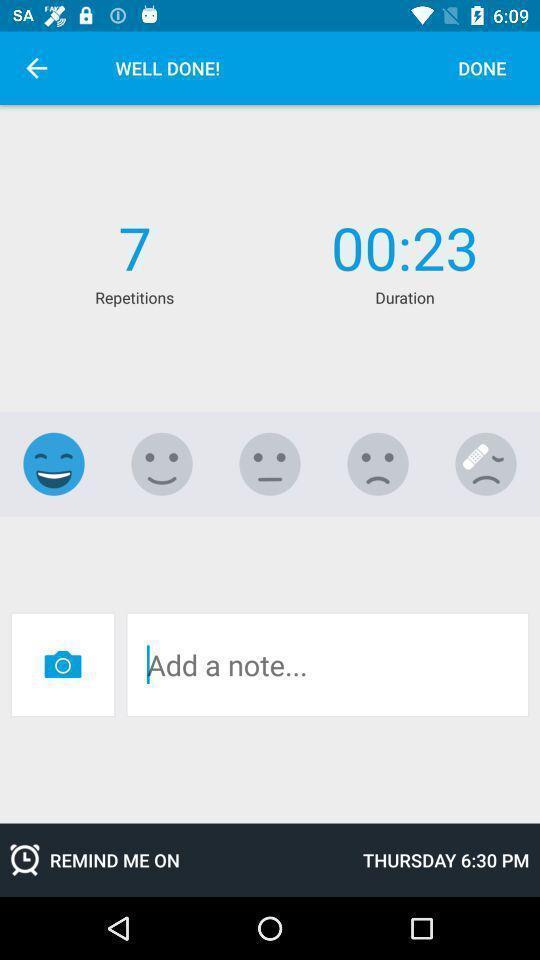Summarize the information in this screenshot. Screen showing duration and repetitions. 